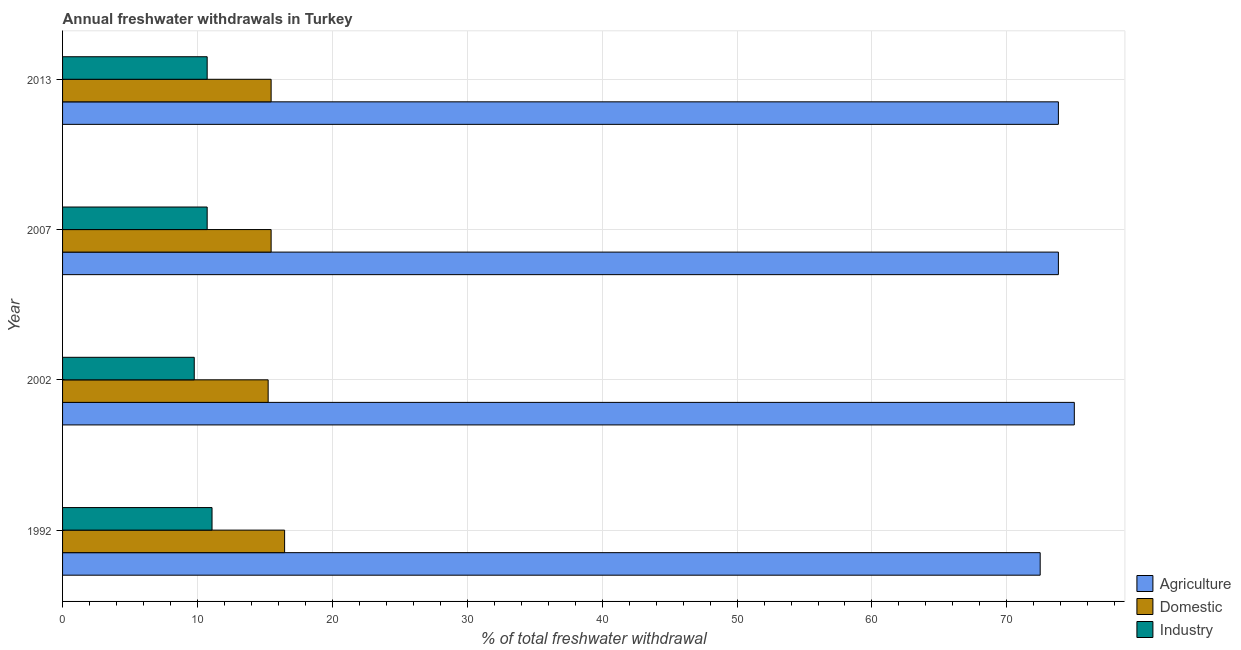How many different coloured bars are there?
Ensure brevity in your answer.  3. How many groups of bars are there?
Provide a succinct answer. 4. Are the number of bars per tick equal to the number of legend labels?
Keep it short and to the point. Yes. Are the number of bars on each tick of the Y-axis equal?
Your answer should be very brief. Yes. How many bars are there on the 3rd tick from the top?
Make the answer very short. 3. How many bars are there on the 2nd tick from the bottom?
Your answer should be compact. 3. What is the label of the 3rd group of bars from the top?
Provide a short and direct response. 2002. In how many cases, is the number of bars for a given year not equal to the number of legend labels?
Make the answer very short. 0. What is the percentage of freshwater withdrawal for agriculture in 2007?
Your answer should be very brief. 73.82. Across all years, what is the maximum percentage of freshwater withdrawal for domestic purposes?
Your answer should be compact. 16.46. Across all years, what is the minimum percentage of freshwater withdrawal for agriculture?
Keep it short and to the point. 72.47. What is the total percentage of freshwater withdrawal for industry in the graph?
Your answer should be very brief. 42.28. What is the difference between the percentage of freshwater withdrawal for industry in 1992 and the percentage of freshwater withdrawal for agriculture in 2002?
Your answer should be very brief. -63.92. What is the average percentage of freshwater withdrawal for industry per year?
Make the answer very short. 10.57. In the year 2002, what is the difference between the percentage of freshwater withdrawal for industry and percentage of freshwater withdrawal for agriculture?
Offer a very short reply. -65.24. In how many years, is the percentage of freshwater withdrawal for agriculture greater than 14 %?
Your response must be concise. 4. Is the percentage of freshwater withdrawal for agriculture in 1992 less than that in 2002?
Ensure brevity in your answer.  Yes. Is the difference between the percentage of freshwater withdrawal for domestic purposes in 2007 and 2013 greater than the difference between the percentage of freshwater withdrawal for agriculture in 2007 and 2013?
Offer a terse response. No. What is the difference between the highest and the second highest percentage of freshwater withdrawal for agriculture?
Make the answer very short. 1.18. What is the difference between the highest and the lowest percentage of freshwater withdrawal for domestic purposes?
Give a very brief answer. 1.22. In how many years, is the percentage of freshwater withdrawal for domestic purposes greater than the average percentage of freshwater withdrawal for domestic purposes taken over all years?
Your answer should be very brief. 1. What does the 1st bar from the top in 2002 represents?
Your answer should be very brief. Industry. What does the 1st bar from the bottom in 2013 represents?
Provide a succinct answer. Agriculture. Are all the bars in the graph horizontal?
Your answer should be very brief. Yes. How many years are there in the graph?
Offer a very short reply. 4. Are the values on the major ticks of X-axis written in scientific E-notation?
Your answer should be compact. No. Where does the legend appear in the graph?
Provide a succinct answer. Bottom right. How are the legend labels stacked?
Your response must be concise. Vertical. What is the title of the graph?
Ensure brevity in your answer.  Annual freshwater withdrawals in Turkey. What is the label or title of the X-axis?
Keep it short and to the point. % of total freshwater withdrawal. What is the label or title of the Y-axis?
Offer a very short reply. Year. What is the % of total freshwater withdrawal in Agriculture in 1992?
Provide a succinct answer. 72.47. What is the % of total freshwater withdrawal of Domestic in 1992?
Offer a very short reply. 16.46. What is the % of total freshwater withdrawal of Industry in 1992?
Give a very brief answer. 11.08. What is the % of total freshwater withdrawal in Agriculture in 2002?
Provide a succinct answer. 75. What is the % of total freshwater withdrawal of Domestic in 2002?
Provide a short and direct response. 15.24. What is the % of total freshwater withdrawal in Industry in 2002?
Ensure brevity in your answer.  9.76. What is the % of total freshwater withdrawal in Agriculture in 2007?
Give a very brief answer. 73.82. What is the % of total freshwater withdrawal in Domestic in 2007?
Provide a short and direct response. 15.46. What is the % of total freshwater withdrawal in Industry in 2007?
Your answer should be very brief. 10.72. What is the % of total freshwater withdrawal in Agriculture in 2013?
Give a very brief answer. 73.82. What is the % of total freshwater withdrawal in Domestic in 2013?
Keep it short and to the point. 15.46. What is the % of total freshwater withdrawal of Industry in 2013?
Offer a very short reply. 10.72. Across all years, what is the maximum % of total freshwater withdrawal of Agriculture?
Provide a succinct answer. 75. Across all years, what is the maximum % of total freshwater withdrawal in Domestic?
Your answer should be very brief. 16.46. Across all years, what is the maximum % of total freshwater withdrawal of Industry?
Make the answer very short. 11.08. Across all years, what is the minimum % of total freshwater withdrawal of Agriculture?
Give a very brief answer. 72.47. Across all years, what is the minimum % of total freshwater withdrawal in Domestic?
Provide a succinct answer. 15.24. Across all years, what is the minimum % of total freshwater withdrawal of Industry?
Ensure brevity in your answer.  9.76. What is the total % of total freshwater withdrawal of Agriculture in the graph?
Offer a terse response. 295.11. What is the total % of total freshwater withdrawal of Domestic in the graph?
Your response must be concise. 62.62. What is the total % of total freshwater withdrawal in Industry in the graph?
Offer a very short reply. 42.28. What is the difference between the % of total freshwater withdrawal in Agriculture in 1992 and that in 2002?
Your response must be concise. -2.53. What is the difference between the % of total freshwater withdrawal of Domestic in 1992 and that in 2002?
Your response must be concise. 1.22. What is the difference between the % of total freshwater withdrawal of Industry in 1992 and that in 2002?
Provide a succinct answer. 1.32. What is the difference between the % of total freshwater withdrawal in Agriculture in 1992 and that in 2007?
Give a very brief answer. -1.35. What is the difference between the % of total freshwater withdrawal of Industry in 1992 and that in 2007?
Your response must be concise. 0.36. What is the difference between the % of total freshwater withdrawal of Agriculture in 1992 and that in 2013?
Ensure brevity in your answer.  -1.35. What is the difference between the % of total freshwater withdrawal in Domestic in 1992 and that in 2013?
Make the answer very short. 1. What is the difference between the % of total freshwater withdrawal in Industry in 1992 and that in 2013?
Give a very brief answer. 0.36. What is the difference between the % of total freshwater withdrawal in Agriculture in 2002 and that in 2007?
Your response must be concise. 1.18. What is the difference between the % of total freshwater withdrawal in Domestic in 2002 and that in 2007?
Your response must be concise. -0.22. What is the difference between the % of total freshwater withdrawal in Industry in 2002 and that in 2007?
Offer a very short reply. -0.96. What is the difference between the % of total freshwater withdrawal in Agriculture in 2002 and that in 2013?
Your response must be concise. 1.18. What is the difference between the % of total freshwater withdrawal in Domestic in 2002 and that in 2013?
Offer a terse response. -0.22. What is the difference between the % of total freshwater withdrawal of Industry in 2002 and that in 2013?
Offer a very short reply. -0.96. What is the difference between the % of total freshwater withdrawal of Agriculture in 2007 and that in 2013?
Keep it short and to the point. 0. What is the difference between the % of total freshwater withdrawal of Agriculture in 1992 and the % of total freshwater withdrawal of Domestic in 2002?
Keep it short and to the point. 57.23. What is the difference between the % of total freshwater withdrawal of Agriculture in 1992 and the % of total freshwater withdrawal of Industry in 2002?
Your response must be concise. 62.71. What is the difference between the % of total freshwater withdrawal in Domestic in 1992 and the % of total freshwater withdrawal in Industry in 2002?
Offer a very short reply. 6.7. What is the difference between the % of total freshwater withdrawal in Agriculture in 1992 and the % of total freshwater withdrawal in Domestic in 2007?
Your answer should be very brief. 57.01. What is the difference between the % of total freshwater withdrawal of Agriculture in 1992 and the % of total freshwater withdrawal of Industry in 2007?
Your answer should be very brief. 61.75. What is the difference between the % of total freshwater withdrawal of Domestic in 1992 and the % of total freshwater withdrawal of Industry in 2007?
Provide a succinct answer. 5.74. What is the difference between the % of total freshwater withdrawal in Agriculture in 1992 and the % of total freshwater withdrawal in Domestic in 2013?
Your answer should be very brief. 57.01. What is the difference between the % of total freshwater withdrawal of Agriculture in 1992 and the % of total freshwater withdrawal of Industry in 2013?
Your answer should be compact. 61.75. What is the difference between the % of total freshwater withdrawal of Domestic in 1992 and the % of total freshwater withdrawal of Industry in 2013?
Provide a succinct answer. 5.74. What is the difference between the % of total freshwater withdrawal of Agriculture in 2002 and the % of total freshwater withdrawal of Domestic in 2007?
Offer a terse response. 59.54. What is the difference between the % of total freshwater withdrawal in Agriculture in 2002 and the % of total freshwater withdrawal in Industry in 2007?
Provide a succinct answer. 64.28. What is the difference between the % of total freshwater withdrawal of Domestic in 2002 and the % of total freshwater withdrawal of Industry in 2007?
Keep it short and to the point. 4.52. What is the difference between the % of total freshwater withdrawal in Agriculture in 2002 and the % of total freshwater withdrawal in Domestic in 2013?
Your answer should be very brief. 59.54. What is the difference between the % of total freshwater withdrawal in Agriculture in 2002 and the % of total freshwater withdrawal in Industry in 2013?
Keep it short and to the point. 64.28. What is the difference between the % of total freshwater withdrawal of Domestic in 2002 and the % of total freshwater withdrawal of Industry in 2013?
Give a very brief answer. 4.52. What is the difference between the % of total freshwater withdrawal in Agriculture in 2007 and the % of total freshwater withdrawal in Domestic in 2013?
Make the answer very short. 58.36. What is the difference between the % of total freshwater withdrawal of Agriculture in 2007 and the % of total freshwater withdrawal of Industry in 2013?
Provide a succinct answer. 63.1. What is the difference between the % of total freshwater withdrawal in Domestic in 2007 and the % of total freshwater withdrawal in Industry in 2013?
Provide a short and direct response. 4.74. What is the average % of total freshwater withdrawal in Agriculture per year?
Ensure brevity in your answer.  73.78. What is the average % of total freshwater withdrawal of Domestic per year?
Your answer should be compact. 15.65. What is the average % of total freshwater withdrawal of Industry per year?
Keep it short and to the point. 10.57. In the year 1992, what is the difference between the % of total freshwater withdrawal of Agriculture and % of total freshwater withdrawal of Domestic?
Your answer should be compact. 56.01. In the year 1992, what is the difference between the % of total freshwater withdrawal of Agriculture and % of total freshwater withdrawal of Industry?
Provide a short and direct response. 61.39. In the year 1992, what is the difference between the % of total freshwater withdrawal of Domestic and % of total freshwater withdrawal of Industry?
Make the answer very short. 5.38. In the year 2002, what is the difference between the % of total freshwater withdrawal of Agriculture and % of total freshwater withdrawal of Domestic?
Your answer should be compact. 59.76. In the year 2002, what is the difference between the % of total freshwater withdrawal in Agriculture and % of total freshwater withdrawal in Industry?
Make the answer very short. 65.24. In the year 2002, what is the difference between the % of total freshwater withdrawal in Domestic and % of total freshwater withdrawal in Industry?
Offer a terse response. 5.48. In the year 2007, what is the difference between the % of total freshwater withdrawal of Agriculture and % of total freshwater withdrawal of Domestic?
Provide a succinct answer. 58.36. In the year 2007, what is the difference between the % of total freshwater withdrawal of Agriculture and % of total freshwater withdrawal of Industry?
Your response must be concise. 63.1. In the year 2007, what is the difference between the % of total freshwater withdrawal of Domestic and % of total freshwater withdrawal of Industry?
Your answer should be compact. 4.74. In the year 2013, what is the difference between the % of total freshwater withdrawal in Agriculture and % of total freshwater withdrawal in Domestic?
Ensure brevity in your answer.  58.36. In the year 2013, what is the difference between the % of total freshwater withdrawal of Agriculture and % of total freshwater withdrawal of Industry?
Your response must be concise. 63.1. In the year 2013, what is the difference between the % of total freshwater withdrawal in Domestic and % of total freshwater withdrawal in Industry?
Your response must be concise. 4.74. What is the ratio of the % of total freshwater withdrawal of Agriculture in 1992 to that in 2002?
Offer a terse response. 0.97. What is the ratio of the % of total freshwater withdrawal of Domestic in 1992 to that in 2002?
Ensure brevity in your answer.  1.08. What is the ratio of the % of total freshwater withdrawal of Industry in 1992 to that in 2002?
Offer a very short reply. 1.14. What is the ratio of the % of total freshwater withdrawal of Agriculture in 1992 to that in 2007?
Provide a succinct answer. 0.98. What is the ratio of the % of total freshwater withdrawal of Domestic in 1992 to that in 2007?
Your answer should be compact. 1.06. What is the ratio of the % of total freshwater withdrawal of Industry in 1992 to that in 2007?
Give a very brief answer. 1.03. What is the ratio of the % of total freshwater withdrawal of Agriculture in 1992 to that in 2013?
Offer a very short reply. 0.98. What is the ratio of the % of total freshwater withdrawal of Domestic in 1992 to that in 2013?
Your answer should be very brief. 1.06. What is the ratio of the % of total freshwater withdrawal of Industry in 1992 to that in 2013?
Your response must be concise. 1.03. What is the ratio of the % of total freshwater withdrawal of Domestic in 2002 to that in 2007?
Keep it short and to the point. 0.99. What is the ratio of the % of total freshwater withdrawal in Industry in 2002 to that in 2007?
Provide a succinct answer. 0.91. What is the ratio of the % of total freshwater withdrawal of Domestic in 2002 to that in 2013?
Your answer should be very brief. 0.99. What is the ratio of the % of total freshwater withdrawal in Industry in 2002 to that in 2013?
Keep it short and to the point. 0.91. What is the ratio of the % of total freshwater withdrawal in Agriculture in 2007 to that in 2013?
Give a very brief answer. 1. What is the ratio of the % of total freshwater withdrawal in Domestic in 2007 to that in 2013?
Your answer should be very brief. 1. What is the ratio of the % of total freshwater withdrawal in Industry in 2007 to that in 2013?
Make the answer very short. 1. What is the difference between the highest and the second highest % of total freshwater withdrawal in Agriculture?
Offer a very short reply. 1.18. What is the difference between the highest and the second highest % of total freshwater withdrawal in Domestic?
Ensure brevity in your answer.  1. What is the difference between the highest and the second highest % of total freshwater withdrawal of Industry?
Ensure brevity in your answer.  0.36. What is the difference between the highest and the lowest % of total freshwater withdrawal of Agriculture?
Your response must be concise. 2.53. What is the difference between the highest and the lowest % of total freshwater withdrawal of Domestic?
Make the answer very short. 1.22. What is the difference between the highest and the lowest % of total freshwater withdrawal in Industry?
Your answer should be very brief. 1.32. 